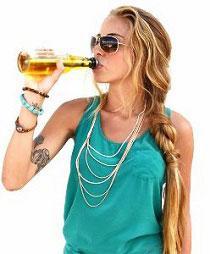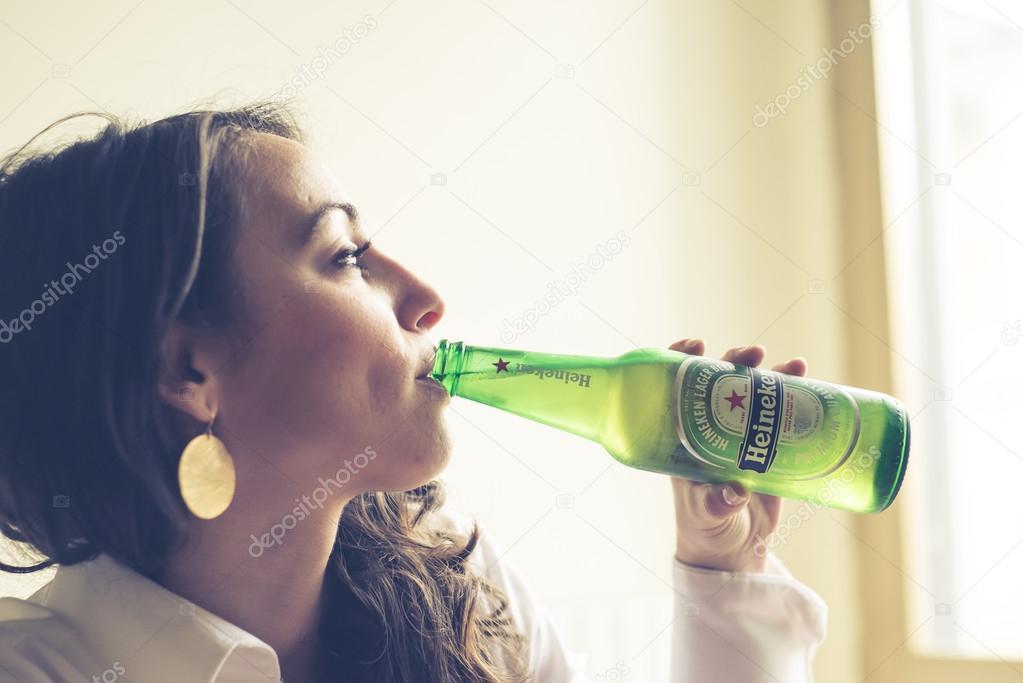The first image is the image on the left, the second image is the image on the right. Considering the images on both sides, is "The woman in the image on the right is lifting a green bottle to her mouth." valid? Answer yes or no. Yes. 